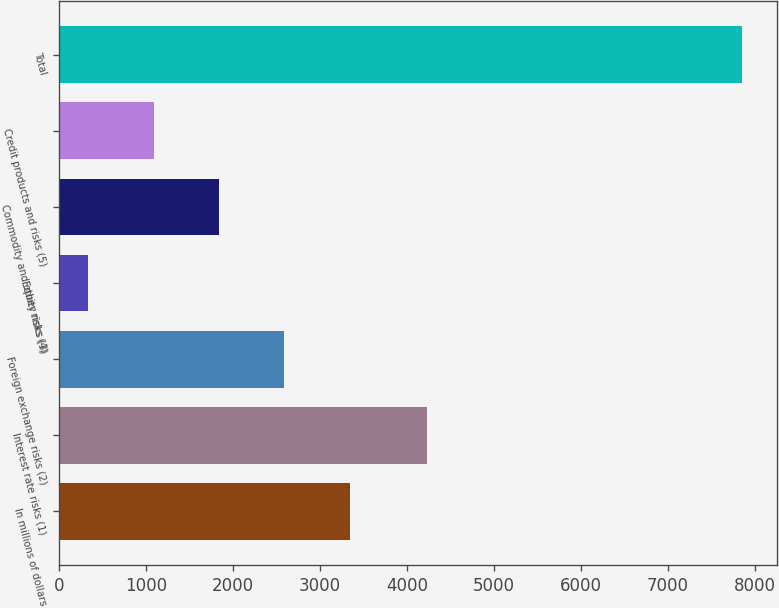Convert chart to OTSL. <chart><loc_0><loc_0><loc_500><loc_500><bar_chart><fcel>In millions of dollars<fcel>Interest rate risks (1)<fcel>Foreign exchange risks (2)<fcel>Equity risks (3)<fcel>Commodity and other risks (4)<fcel>Credit products and risks (5)<fcel>Total<nl><fcel>3340.8<fcel>4229<fcel>2588.1<fcel>330<fcel>1835.4<fcel>1082.7<fcel>7857<nl></chart> 